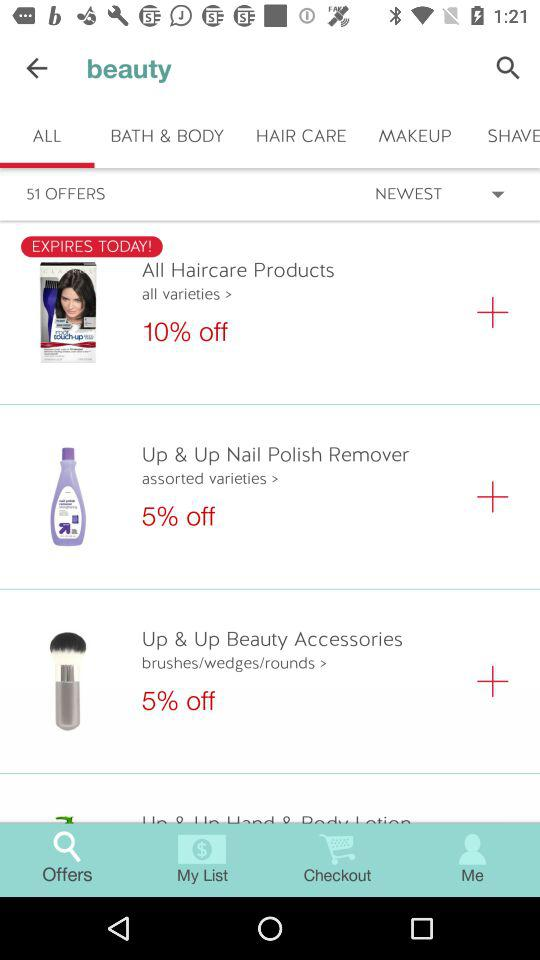What is the total number of offers? The total number of offers is 51. 